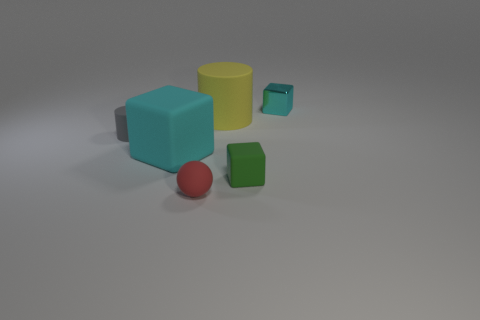What number of other objects are the same color as the small ball?
Provide a succinct answer. 0. Is the shape of the object that is to the left of the cyan rubber cube the same as  the yellow object?
Offer a terse response. Yes. What is the color of the other thing that is the same shape as the large yellow thing?
Offer a terse response. Gray. Are there any other things that are made of the same material as the small cyan object?
Give a very brief answer. No. What is the size of the yellow thing that is the same shape as the gray object?
Keep it short and to the point. Large. There is a thing that is behind the small gray cylinder and right of the yellow cylinder; what material is it?
Make the answer very short. Metal. Do the large rubber thing to the left of the large matte cylinder and the metal cube have the same color?
Make the answer very short. Yes. There is a small metallic cube; is it the same color as the big matte thing that is on the left side of the yellow cylinder?
Your answer should be very brief. Yes. There is a large block; are there any things behind it?
Your answer should be very brief. Yes. Is the big cylinder made of the same material as the gray object?
Keep it short and to the point. Yes. 